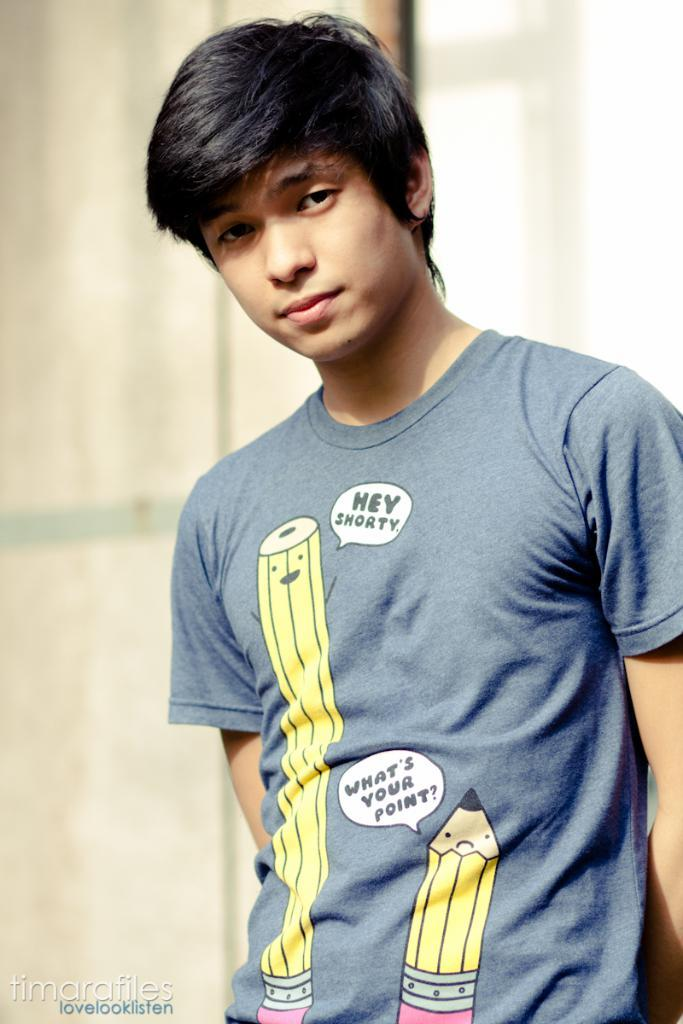<image>
Describe the image concisely. a boy with a funny shirt that says hey shorty 